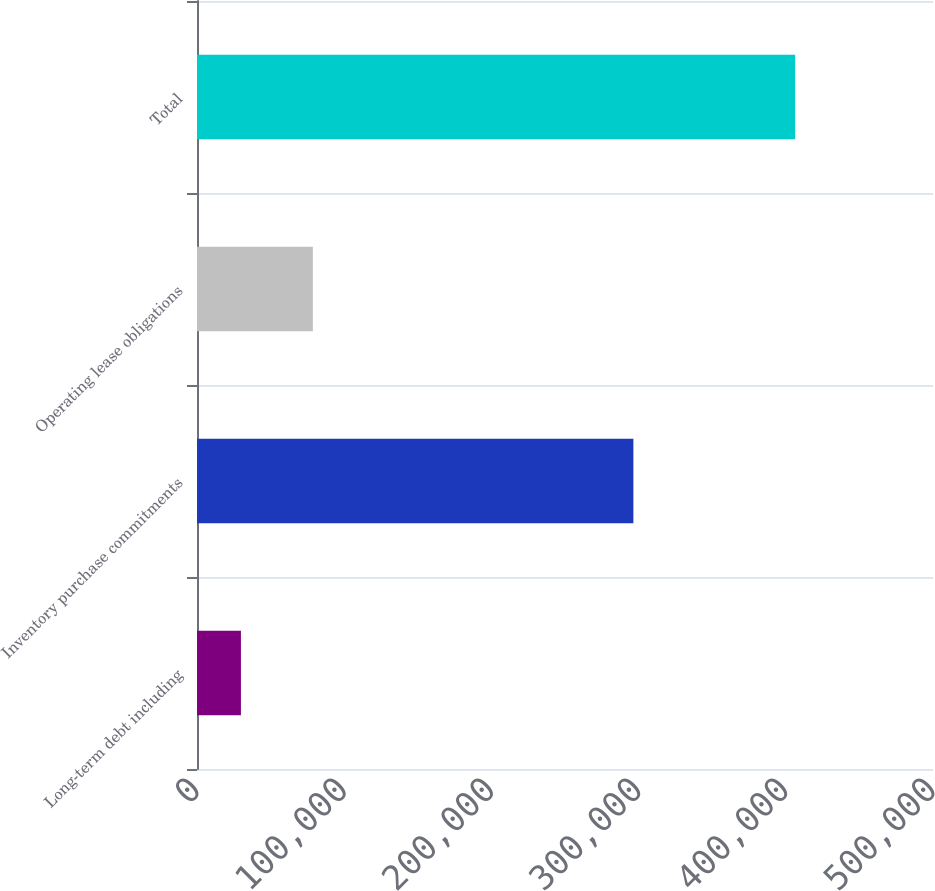Convert chart to OTSL. <chart><loc_0><loc_0><loc_500><loc_500><bar_chart><fcel>Long-term debt including<fcel>Inventory purchase commitments<fcel>Operating lease obligations<fcel>Total<nl><fcel>29841<fcel>296463<fcel>78716<fcel>406337<nl></chart> 